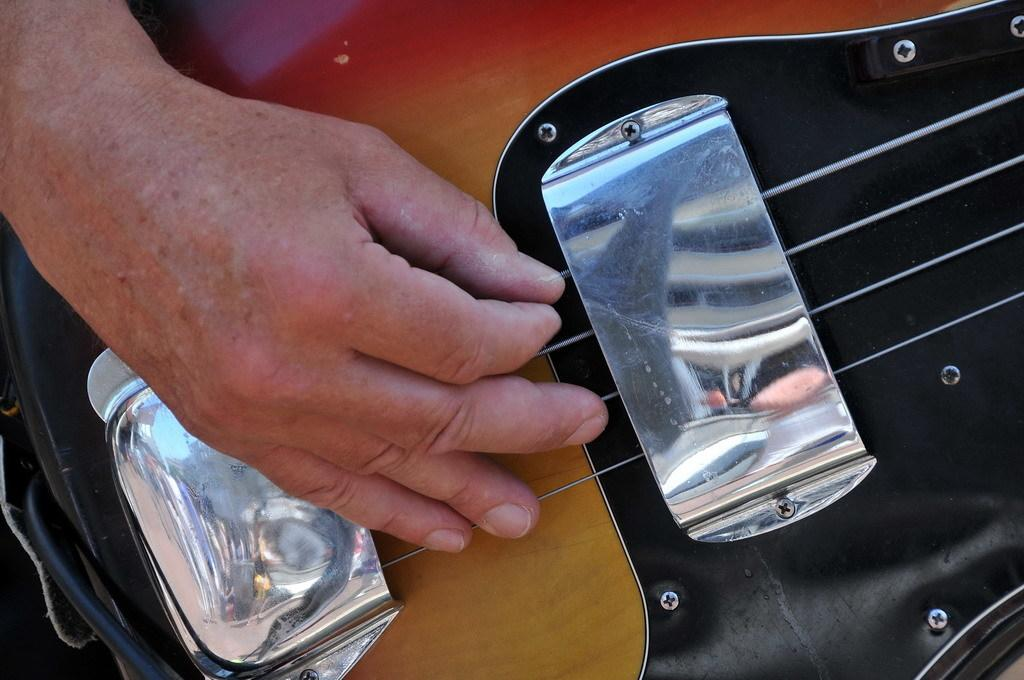What is the main object being held in the image? There is a guitar in the image. What can be seen in the hand of the person in the image? There is a hand holding a guitar in the image. What is the color of the guitar? The guitar is brown in color. What is the person doing with the guitar? The person is playing the guitar. What type of plant is being used to illuminate the room in the image? There is no plant or light source mentioned in the image; it only features a hand holding a brown guitar. 